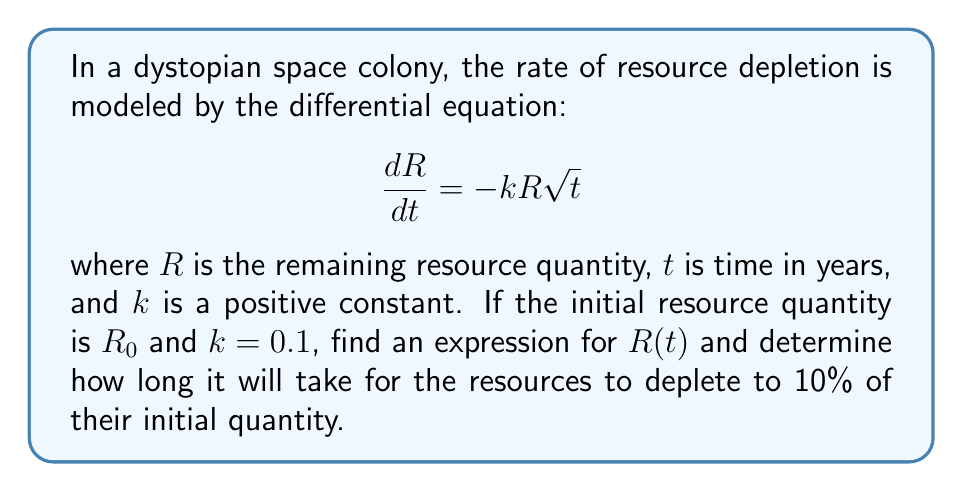Can you answer this question? To solve this first-order differential equation:

1) Separate variables:
   $$\frac{dR}{R} = -k\sqrt{t}dt$$

2) Integrate both sides:
   $$\int \frac{dR}{R} = -k \int \sqrt{t}dt$$

3) Solve the integrals:
   $$\ln|R| = -k \cdot \frac{2}{3}t^{3/2} + C$$

4) Apply the initial condition $R(0) = R_0$:
   $$\ln|R_0| = C$$

5) Substitute back:
   $$\ln|R| = -k \cdot \frac{2}{3}t^{3/2} + \ln|R_0|$$

6) Exponentiate both sides:
   $$R = R_0 \exp(-\frac{2k}{3}t^{3/2})$$

7) To find when $R = 0.1R_0$, solve:
   $$0.1R_0 = R_0 \exp(-\frac{2k}{3}t^{3/2})$$

8) Simplify:
   $$0.1 = \exp(-\frac{2k}{3}t^{3/2})$$

9) Take natural log of both sides:
   $$\ln(0.1) = -\frac{2k}{3}t^{3/2}$$

10) Solve for $t$:
    $$t = \left(-\frac{3\ln(0.1)}{2k}\right)^{2/3}$$

11) Substitute $k = 0.1$:
    $$t = \left(-\frac{3\ln(0.1)}{2(0.1)}\right)^{2/3} \approx 14.47 \text{ years}$$
Answer: The expression for $R(t)$ is $R(t) = R_0 \exp(-\frac{2k}{3}t^{3/2})$. The resources will deplete to 10% of their initial quantity after approximately 14.47 years. 